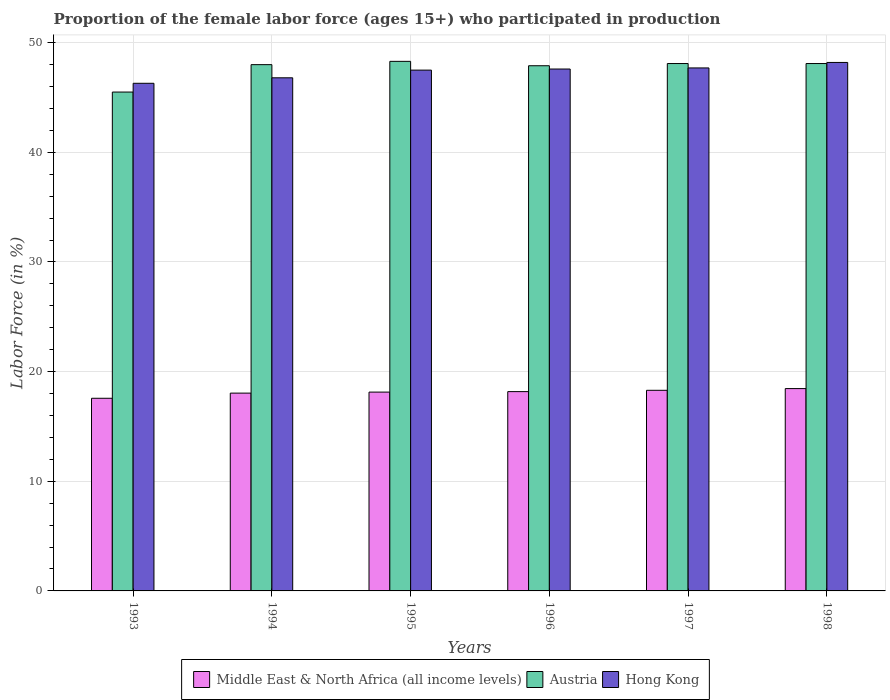Are the number of bars on each tick of the X-axis equal?
Offer a terse response. Yes. How many bars are there on the 5th tick from the left?
Make the answer very short. 3. How many bars are there on the 5th tick from the right?
Offer a very short reply. 3. In how many cases, is the number of bars for a given year not equal to the number of legend labels?
Provide a succinct answer. 0. What is the proportion of the female labor force who participated in production in Middle East & North Africa (all income levels) in 1994?
Give a very brief answer. 18.04. Across all years, what is the maximum proportion of the female labor force who participated in production in Austria?
Ensure brevity in your answer.  48.3. Across all years, what is the minimum proportion of the female labor force who participated in production in Hong Kong?
Your answer should be compact. 46.3. In which year was the proportion of the female labor force who participated in production in Austria maximum?
Make the answer very short. 1995. What is the total proportion of the female labor force who participated in production in Hong Kong in the graph?
Your response must be concise. 284.1. What is the difference between the proportion of the female labor force who participated in production in Austria in 1993 and that in 1996?
Make the answer very short. -2.4. What is the difference between the proportion of the female labor force who participated in production in Hong Kong in 1996 and the proportion of the female labor force who participated in production in Middle East & North Africa (all income levels) in 1994?
Offer a very short reply. 29.56. What is the average proportion of the female labor force who participated in production in Hong Kong per year?
Offer a terse response. 47.35. In the year 1995, what is the difference between the proportion of the female labor force who participated in production in Austria and proportion of the female labor force who participated in production in Middle East & North Africa (all income levels)?
Provide a succinct answer. 30.17. In how many years, is the proportion of the female labor force who participated in production in Austria greater than 12 %?
Your response must be concise. 6. What is the ratio of the proportion of the female labor force who participated in production in Hong Kong in 1993 to that in 1997?
Provide a short and direct response. 0.97. Is the proportion of the female labor force who participated in production in Middle East & North Africa (all income levels) in 1997 less than that in 1998?
Keep it short and to the point. Yes. Is the difference between the proportion of the female labor force who participated in production in Austria in 1993 and 1996 greater than the difference between the proportion of the female labor force who participated in production in Middle East & North Africa (all income levels) in 1993 and 1996?
Your response must be concise. No. What is the difference between the highest and the second highest proportion of the female labor force who participated in production in Middle East & North Africa (all income levels)?
Your answer should be compact. 0.16. What is the difference between the highest and the lowest proportion of the female labor force who participated in production in Middle East & North Africa (all income levels)?
Your answer should be compact. 0.88. In how many years, is the proportion of the female labor force who participated in production in Middle East & North Africa (all income levels) greater than the average proportion of the female labor force who participated in production in Middle East & North Africa (all income levels) taken over all years?
Keep it short and to the point. 4. Is the sum of the proportion of the female labor force who participated in production in Middle East & North Africa (all income levels) in 1993 and 1997 greater than the maximum proportion of the female labor force who participated in production in Austria across all years?
Provide a short and direct response. No. What does the 1st bar from the left in 1997 represents?
Make the answer very short. Middle East & North Africa (all income levels). What does the 2nd bar from the right in 1993 represents?
Your answer should be compact. Austria. Is it the case that in every year, the sum of the proportion of the female labor force who participated in production in Middle East & North Africa (all income levels) and proportion of the female labor force who participated in production in Hong Kong is greater than the proportion of the female labor force who participated in production in Austria?
Keep it short and to the point. Yes. How many years are there in the graph?
Offer a terse response. 6. What is the difference between two consecutive major ticks on the Y-axis?
Your answer should be compact. 10. Does the graph contain grids?
Ensure brevity in your answer.  Yes. Where does the legend appear in the graph?
Your answer should be very brief. Bottom center. How are the legend labels stacked?
Keep it short and to the point. Horizontal. What is the title of the graph?
Your answer should be very brief. Proportion of the female labor force (ages 15+) who participated in production. Does "Curacao" appear as one of the legend labels in the graph?
Your answer should be compact. No. What is the label or title of the Y-axis?
Keep it short and to the point. Labor Force (in %). What is the Labor Force (in %) of Middle East & North Africa (all income levels) in 1993?
Offer a very short reply. 17.57. What is the Labor Force (in %) of Austria in 1993?
Your answer should be very brief. 45.5. What is the Labor Force (in %) in Hong Kong in 1993?
Offer a terse response. 46.3. What is the Labor Force (in %) of Middle East & North Africa (all income levels) in 1994?
Give a very brief answer. 18.04. What is the Labor Force (in %) in Hong Kong in 1994?
Ensure brevity in your answer.  46.8. What is the Labor Force (in %) of Middle East & North Africa (all income levels) in 1995?
Your response must be concise. 18.13. What is the Labor Force (in %) in Austria in 1995?
Your response must be concise. 48.3. What is the Labor Force (in %) in Hong Kong in 1995?
Your answer should be compact. 47.5. What is the Labor Force (in %) in Middle East & North Africa (all income levels) in 1996?
Give a very brief answer. 18.18. What is the Labor Force (in %) of Austria in 1996?
Give a very brief answer. 47.9. What is the Labor Force (in %) of Hong Kong in 1996?
Provide a short and direct response. 47.6. What is the Labor Force (in %) of Middle East & North Africa (all income levels) in 1997?
Your response must be concise. 18.3. What is the Labor Force (in %) in Austria in 1997?
Keep it short and to the point. 48.1. What is the Labor Force (in %) in Hong Kong in 1997?
Provide a succinct answer. 47.7. What is the Labor Force (in %) in Middle East & North Africa (all income levels) in 1998?
Provide a short and direct response. 18.45. What is the Labor Force (in %) in Austria in 1998?
Keep it short and to the point. 48.1. What is the Labor Force (in %) in Hong Kong in 1998?
Your answer should be compact. 48.2. Across all years, what is the maximum Labor Force (in %) in Middle East & North Africa (all income levels)?
Keep it short and to the point. 18.45. Across all years, what is the maximum Labor Force (in %) in Austria?
Provide a succinct answer. 48.3. Across all years, what is the maximum Labor Force (in %) of Hong Kong?
Provide a short and direct response. 48.2. Across all years, what is the minimum Labor Force (in %) in Middle East & North Africa (all income levels)?
Give a very brief answer. 17.57. Across all years, what is the minimum Labor Force (in %) in Austria?
Provide a succinct answer. 45.5. Across all years, what is the minimum Labor Force (in %) of Hong Kong?
Offer a terse response. 46.3. What is the total Labor Force (in %) of Middle East & North Africa (all income levels) in the graph?
Provide a short and direct response. 108.68. What is the total Labor Force (in %) of Austria in the graph?
Your answer should be compact. 285.9. What is the total Labor Force (in %) of Hong Kong in the graph?
Offer a terse response. 284.1. What is the difference between the Labor Force (in %) in Middle East & North Africa (all income levels) in 1993 and that in 1994?
Ensure brevity in your answer.  -0.47. What is the difference between the Labor Force (in %) in Austria in 1993 and that in 1994?
Provide a short and direct response. -2.5. What is the difference between the Labor Force (in %) of Hong Kong in 1993 and that in 1994?
Keep it short and to the point. -0.5. What is the difference between the Labor Force (in %) of Middle East & North Africa (all income levels) in 1993 and that in 1995?
Provide a short and direct response. -0.56. What is the difference between the Labor Force (in %) of Hong Kong in 1993 and that in 1995?
Keep it short and to the point. -1.2. What is the difference between the Labor Force (in %) in Middle East & North Africa (all income levels) in 1993 and that in 1996?
Ensure brevity in your answer.  -0.61. What is the difference between the Labor Force (in %) of Austria in 1993 and that in 1996?
Ensure brevity in your answer.  -2.4. What is the difference between the Labor Force (in %) in Middle East & North Africa (all income levels) in 1993 and that in 1997?
Your answer should be very brief. -0.73. What is the difference between the Labor Force (in %) in Middle East & North Africa (all income levels) in 1993 and that in 1998?
Offer a terse response. -0.88. What is the difference between the Labor Force (in %) of Austria in 1993 and that in 1998?
Your answer should be very brief. -2.6. What is the difference between the Labor Force (in %) in Hong Kong in 1993 and that in 1998?
Make the answer very short. -1.9. What is the difference between the Labor Force (in %) of Middle East & North Africa (all income levels) in 1994 and that in 1995?
Give a very brief answer. -0.09. What is the difference between the Labor Force (in %) of Austria in 1994 and that in 1995?
Offer a very short reply. -0.3. What is the difference between the Labor Force (in %) of Middle East & North Africa (all income levels) in 1994 and that in 1996?
Offer a very short reply. -0.14. What is the difference between the Labor Force (in %) of Hong Kong in 1994 and that in 1996?
Provide a short and direct response. -0.8. What is the difference between the Labor Force (in %) of Middle East & North Africa (all income levels) in 1994 and that in 1997?
Ensure brevity in your answer.  -0.26. What is the difference between the Labor Force (in %) of Middle East & North Africa (all income levels) in 1994 and that in 1998?
Your answer should be very brief. -0.41. What is the difference between the Labor Force (in %) in Middle East & North Africa (all income levels) in 1995 and that in 1996?
Provide a short and direct response. -0.05. What is the difference between the Labor Force (in %) in Hong Kong in 1995 and that in 1996?
Provide a succinct answer. -0.1. What is the difference between the Labor Force (in %) of Middle East & North Africa (all income levels) in 1995 and that in 1997?
Keep it short and to the point. -0.16. What is the difference between the Labor Force (in %) of Hong Kong in 1995 and that in 1997?
Your answer should be compact. -0.2. What is the difference between the Labor Force (in %) of Middle East & North Africa (all income levels) in 1995 and that in 1998?
Keep it short and to the point. -0.32. What is the difference between the Labor Force (in %) in Austria in 1995 and that in 1998?
Make the answer very short. 0.2. What is the difference between the Labor Force (in %) of Middle East & North Africa (all income levels) in 1996 and that in 1997?
Your response must be concise. -0.12. What is the difference between the Labor Force (in %) in Hong Kong in 1996 and that in 1997?
Provide a succinct answer. -0.1. What is the difference between the Labor Force (in %) of Middle East & North Africa (all income levels) in 1996 and that in 1998?
Your answer should be very brief. -0.28. What is the difference between the Labor Force (in %) in Austria in 1996 and that in 1998?
Your answer should be compact. -0.2. What is the difference between the Labor Force (in %) of Hong Kong in 1996 and that in 1998?
Keep it short and to the point. -0.6. What is the difference between the Labor Force (in %) in Middle East & North Africa (all income levels) in 1997 and that in 1998?
Give a very brief answer. -0.16. What is the difference between the Labor Force (in %) in Hong Kong in 1997 and that in 1998?
Offer a very short reply. -0.5. What is the difference between the Labor Force (in %) in Middle East & North Africa (all income levels) in 1993 and the Labor Force (in %) in Austria in 1994?
Offer a terse response. -30.43. What is the difference between the Labor Force (in %) in Middle East & North Africa (all income levels) in 1993 and the Labor Force (in %) in Hong Kong in 1994?
Provide a succinct answer. -29.23. What is the difference between the Labor Force (in %) of Austria in 1993 and the Labor Force (in %) of Hong Kong in 1994?
Offer a terse response. -1.3. What is the difference between the Labor Force (in %) in Middle East & North Africa (all income levels) in 1993 and the Labor Force (in %) in Austria in 1995?
Provide a short and direct response. -30.73. What is the difference between the Labor Force (in %) of Middle East & North Africa (all income levels) in 1993 and the Labor Force (in %) of Hong Kong in 1995?
Make the answer very short. -29.93. What is the difference between the Labor Force (in %) in Austria in 1993 and the Labor Force (in %) in Hong Kong in 1995?
Provide a succinct answer. -2. What is the difference between the Labor Force (in %) of Middle East & North Africa (all income levels) in 1993 and the Labor Force (in %) of Austria in 1996?
Provide a succinct answer. -30.33. What is the difference between the Labor Force (in %) of Middle East & North Africa (all income levels) in 1993 and the Labor Force (in %) of Hong Kong in 1996?
Offer a very short reply. -30.03. What is the difference between the Labor Force (in %) in Middle East & North Africa (all income levels) in 1993 and the Labor Force (in %) in Austria in 1997?
Your answer should be compact. -30.53. What is the difference between the Labor Force (in %) of Middle East & North Africa (all income levels) in 1993 and the Labor Force (in %) of Hong Kong in 1997?
Make the answer very short. -30.13. What is the difference between the Labor Force (in %) of Middle East & North Africa (all income levels) in 1993 and the Labor Force (in %) of Austria in 1998?
Your answer should be compact. -30.53. What is the difference between the Labor Force (in %) in Middle East & North Africa (all income levels) in 1993 and the Labor Force (in %) in Hong Kong in 1998?
Your response must be concise. -30.63. What is the difference between the Labor Force (in %) of Austria in 1993 and the Labor Force (in %) of Hong Kong in 1998?
Give a very brief answer. -2.7. What is the difference between the Labor Force (in %) in Middle East & North Africa (all income levels) in 1994 and the Labor Force (in %) in Austria in 1995?
Give a very brief answer. -30.26. What is the difference between the Labor Force (in %) in Middle East & North Africa (all income levels) in 1994 and the Labor Force (in %) in Hong Kong in 1995?
Provide a succinct answer. -29.46. What is the difference between the Labor Force (in %) of Middle East & North Africa (all income levels) in 1994 and the Labor Force (in %) of Austria in 1996?
Provide a succinct answer. -29.86. What is the difference between the Labor Force (in %) of Middle East & North Africa (all income levels) in 1994 and the Labor Force (in %) of Hong Kong in 1996?
Your response must be concise. -29.56. What is the difference between the Labor Force (in %) of Middle East & North Africa (all income levels) in 1994 and the Labor Force (in %) of Austria in 1997?
Your response must be concise. -30.06. What is the difference between the Labor Force (in %) of Middle East & North Africa (all income levels) in 1994 and the Labor Force (in %) of Hong Kong in 1997?
Provide a short and direct response. -29.66. What is the difference between the Labor Force (in %) of Middle East & North Africa (all income levels) in 1994 and the Labor Force (in %) of Austria in 1998?
Your answer should be compact. -30.06. What is the difference between the Labor Force (in %) in Middle East & North Africa (all income levels) in 1994 and the Labor Force (in %) in Hong Kong in 1998?
Your response must be concise. -30.16. What is the difference between the Labor Force (in %) in Austria in 1994 and the Labor Force (in %) in Hong Kong in 1998?
Provide a short and direct response. -0.2. What is the difference between the Labor Force (in %) of Middle East & North Africa (all income levels) in 1995 and the Labor Force (in %) of Austria in 1996?
Give a very brief answer. -29.77. What is the difference between the Labor Force (in %) of Middle East & North Africa (all income levels) in 1995 and the Labor Force (in %) of Hong Kong in 1996?
Your response must be concise. -29.47. What is the difference between the Labor Force (in %) of Austria in 1995 and the Labor Force (in %) of Hong Kong in 1996?
Your answer should be compact. 0.7. What is the difference between the Labor Force (in %) of Middle East & North Africa (all income levels) in 1995 and the Labor Force (in %) of Austria in 1997?
Your response must be concise. -29.97. What is the difference between the Labor Force (in %) of Middle East & North Africa (all income levels) in 1995 and the Labor Force (in %) of Hong Kong in 1997?
Provide a short and direct response. -29.57. What is the difference between the Labor Force (in %) of Middle East & North Africa (all income levels) in 1995 and the Labor Force (in %) of Austria in 1998?
Your answer should be very brief. -29.97. What is the difference between the Labor Force (in %) in Middle East & North Africa (all income levels) in 1995 and the Labor Force (in %) in Hong Kong in 1998?
Provide a short and direct response. -30.07. What is the difference between the Labor Force (in %) of Middle East & North Africa (all income levels) in 1996 and the Labor Force (in %) of Austria in 1997?
Ensure brevity in your answer.  -29.92. What is the difference between the Labor Force (in %) of Middle East & North Africa (all income levels) in 1996 and the Labor Force (in %) of Hong Kong in 1997?
Provide a short and direct response. -29.52. What is the difference between the Labor Force (in %) of Austria in 1996 and the Labor Force (in %) of Hong Kong in 1997?
Your answer should be very brief. 0.2. What is the difference between the Labor Force (in %) in Middle East & North Africa (all income levels) in 1996 and the Labor Force (in %) in Austria in 1998?
Offer a very short reply. -29.92. What is the difference between the Labor Force (in %) in Middle East & North Africa (all income levels) in 1996 and the Labor Force (in %) in Hong Kong in 1998?
Make the answer very short. -30.02. What is the difference between the Labor Force (in %) of Middle East & North Africa (all income levels) in 1997 and the Labor Force (in %) of Austria in 1998?
Ensure brevity in your answer.  -29.8. What is the difference between the Labor Force (in %) of Middle East & North Africa (all income levels) in 1997 and the Labor Force (in %) of Hong Kong in 1998?
Offer a very short reply. -29.9. What is the difference between the Labor Force (in %) in Austria in 1997 and the Labor Force (in %) in Hong Kong in 1998?
Provide a short and direct response. -0.1. What is the average Labor Force (in %) in Middle East & North Africa (all income levels) per year?
Your answer should be very brief. 18.11. What is the average Labor Force (in %) in Austria per year?
Provide a short and direct response. 47.65. What is the average Labor Force (in %) in Hong Kong per year?
Ensure brevity in your answer.  47.35. In the year 1993, what is the difference between the Labor Force (in %) of Middle East & North Africa (all income levels) and Labor Force (in %) of Austria?
Ensure brevity in your answer.  -27.93. In the year 1993, what is the difference between the Labor Force (in %) in Middle East & North Africa (all income levels) and Labor Force (in %) in Hong Kong?
Ensure brevity in your answer.  -28.73. In the year 1994, what is the difference between the Labor Force (in %) in Middle East & North Africa (all income levels) and Labor Force (in %) in Austria?
Offer a very short reply. -29.96. In the year 1994, what is the difference between the Labor Force (in %) in Middle East & North Africa (all income levels) and Labor Force (in %) in Hong Kong?
Provide a succinct answer. -28.76. In the year 1994, what is the difference between the Labor Force (in %) of Austria and Labor Force (in %) of Hong Kong?
Make the answer very short. 1.2. In the year 1995, what is the difference between the Labor Force (in %) of Middle East & North Africa (all income levels) and Labor Force (in %) of Austria?
Provide a succinct answer. -30.17. In the year 1995, what is the difference between the Labor Force (in %) of Middle East & North Africa (all income levels) and Labor Force (in %) of Hong Kong?
Your answer should be very brief. -29.37. In the year 1996, what is the difference between the Labor Force (in %) of Middle East & North Africa (all income levels) and Labor Force (in %) of Austria?
Your answer should be compact. -29.72. In the year 1996, what is the difference between the Labor Force (in %) of Middle East & North Africa (all income levels) and Labor Force (in %) of Hong Kong?
Your response must be concise. -29.42. In the year 1996, what is the difference between the Labor Force (in %) of Austria and Labor Force (in %) of Hong Kong?
Your answer should be compact. 0.3. In the year 1997, what is the difference between the Labor Force (in %) in Middle East & North Africa (all income levels) and Labor Force (in %) in Austria?
Your answer should be compact. -29.8. In the year 1997, what is the difference between the Labor Force (in %) in Middle East & North Africa (all income levels) and Labor Force (in %) in Hong Kong?
Ensure brevity in your answer.  -29.4. In the year 1998, what is the difference between the Labor Force (in %) in Middle East & North Africa (all income levels) and Labor Force (in %) in Austria?
Your response must be concise. -29.65. In the year 1998, what is the difference between the Labor Force (in %) of Middle East & North Africa (all income levels) and Labor Force (in %) of Hong Kong?
Ensure brevity in your answer.  -29.75. What is the ratio of the Labor Force (in %) of Middle East & North Africa (all income levels) in 1993 to that in 1994?
Keep it short and to the point. 0.97. What is the ratio of the Labor Force (in %) of Austria in 1993 to that in 1994?
Your response must be concise. 0.95. What is the ratio of the Labor Force (in %) of Hong Kong in 1993 to that in 1994?
Offer a terse response. 0.99. What is the ratio of the Labor Force (in %) in Austria in 1993 to that in 1995?
Your answer should be very brief. 0.94. What is the ratio of the Labor Force (in %) of Hong Kong in 1993 to that in 1995?
Provide a succinct answer. 0.97. What is the ratio of the Labor Force (in %) of Middle East & North Africa (all income levels) in 1993 to that in 1996?
Your answer should be compact. 0.97. What is the ratio of the Labor Force (in %) in Austria in 1993 to that in 1996?
Your answer should be very brief. 0.95. What is the ratio of the Labor Force (in %) in Hong Kong in 1993 to that in 1996?
Ensure brevity in your answer.  0.97. What is the ratio of the Labor Force (in %) in Middle East & North Africa (all income levels) in 1993 to that in 1997?
Your response must be concise. 0.96. What is the ratio of the Labor Force (in %) of Austria in 1993 to that in 1997?
Your answer should be compact. 0.95. What is the ratio of the Labor Force (in %) of Hong Kong in 1993 to that in 1997?
Your answer should be very brief. 0.97. What is the ratio of the Labor Force (in %) in Middle East & North Africa (all income levels) in 1993 to that in 1998?
Your answer should be compact. 0.95. What is the ratio of the Labor Force (in %) of Austria in 1993 to that in 1998?
Give a very brief answer. 0.95. What is the ratio of the Labor Force (in %) in Hong Kong in 1993 to that in 1998?
Your answer should be compact. 0.96. What is the ratio of the Labor Force (in %) of Middle East & North Africa (all income levels) in 1994 to that in 1996?
Your answer should be very brief. 0.99. What is the ratio of the Labor Force (in %) in Austria in 1994 to that in 1996?
Give a very brief answer. 1. What is the ratio of the Labor Force (in %) in Hong Kong in 1994 to that in 1996?
Your answer should be very brief. 0.98. What is the ratio of the Labor Force (in %) in Middle East & North Africa (all income levels) in 1994 to that in 1997?
Your answer should be compact. 0.99. What is the ratio of the Labor Force (in %) of Austria in 1994 to that in 1997?
Provide a succinct answer. 1. What is the ratio of the Labor Force (in %) of Hong Kong in 1994 to that in 1997?
Provide a succinct answer. 0.98. What is the ratio of the Labor Force (in %) of Middle East & North Africa (all income levels) in 1994 to that in 1998?
Offer a terse response. 0.98. What is the ratio of the Labor Force (in %) of Austria in 1994 to that in 1998?
Offer a very short reply. 1. What is the ratio of the Labor Force (in %) of Austria in 1995 to that in 1996?
Your response must be concise. 1.01. What is the ratio of the Labor Force (in %) of Hong Kong in 1995 to that in 1996?
Provide a short and direct response. 1. What is the ratio of the Labor Force (in %) in Hong Kong in 1995 to that in 1997?
Provide a short and direct response. 1. What is the ratio of the Labor Force (in %) of Middle East & North Africa (all income levels) in 1995 to that in 1998?
Offer a very short reply. 0.98. What is the ratio of the Labor Force (in %) of Hong Kong in 1995 to that in 1998?
Your answer should be very brief. 0.99. What is the ratio of the Labor Force (in %) of Middle East & North Africa (all income levels) in 1996 to that in 1997?
Make the answer very short. 0.99. What is the ratio of the Labor Force (in %) in Austria in 1996 to that in 1997?
Your answer should be very brief. 1. What is the ratio of the Labor Force (in %) in Hong Kong in 1996 to that in 1997?
Your response must be concise. 1. What is the ratio of the Labor Force (in %) of Middle East & North Africa (all income levels) in 1996 to that in 1998?
Provide a succinct answer. 0.99. What is the ratio of the Labor Force (in %) of Hong Kong in 1996 to that in 1998?
Offer a terse response. 0.99. What is the ratio of the Labor Force (in %) of Middle East & North Africa (all income levels) in 1997 to that in 1998?
Your answer should be very brief. 0.99. What is the ratio of the Labor Force (in %) of Hong Kong in 1997 to that in 1998?
Provide a short and direct response. 0.99. What is the difference between the highest and the second highest Labor Force (in %) of Middle East & North Africa (all income levels)?
Keep it short and to the point. 0.16. What is the difference between the highest and the second highest Labor Force (in %) in Austria?
Provide a succinct answer. 0.2. What is the difference between the highest and the lowest Labor Force (in %) in Middle East & North Africa (all income levels)?
Offer a terse response. 0.88. What is the difference between the highest and the lowest Labor Force (in %) of Austria?
Your answer should be very brief. 2.8. What is the difference between the highest and the lowest Labor Force (in %) in Hong Kong?
Your answer should be compact. 1.9. 